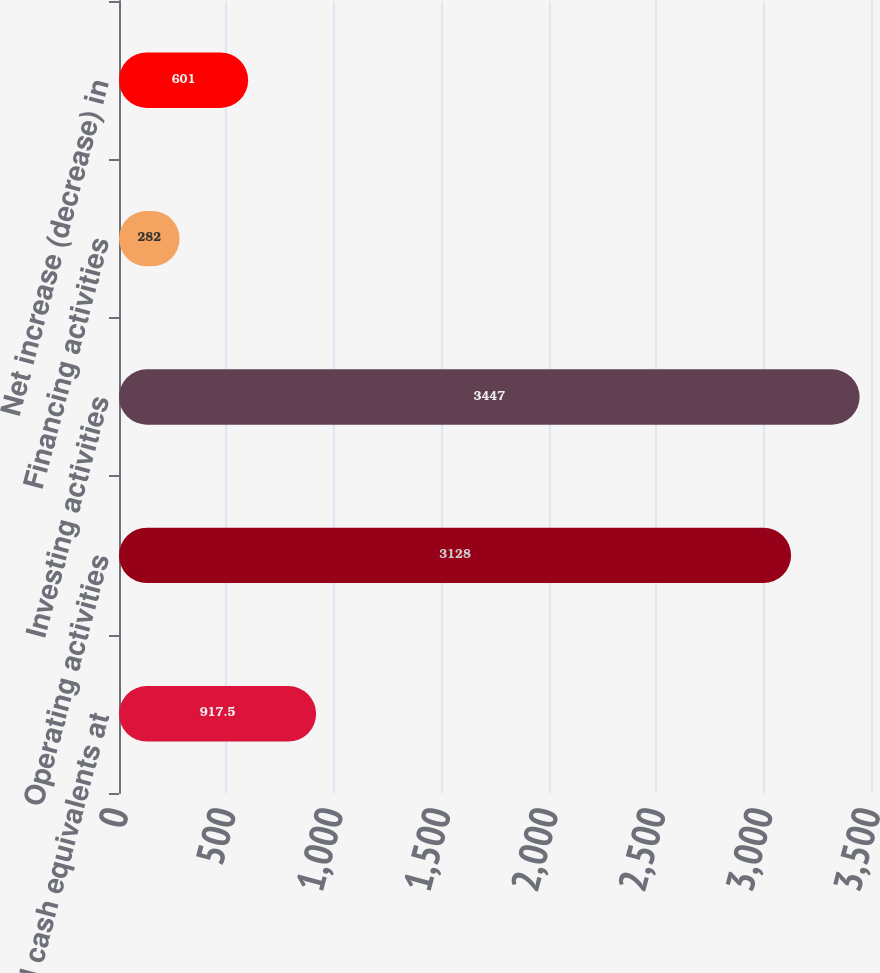<chart> <loc_0><loc_0><loc_500><loc_500><bar_chart><fcel>Cash and cash equivalents at<fcel>Operating activities<fcel>Investing activities<fcel>Financing activities<fcel>Net increase (decrease) in<nl><fcel>917.5<fcel>3128<fcel>3447<fcel>282<fcel>601<nl></chart> 